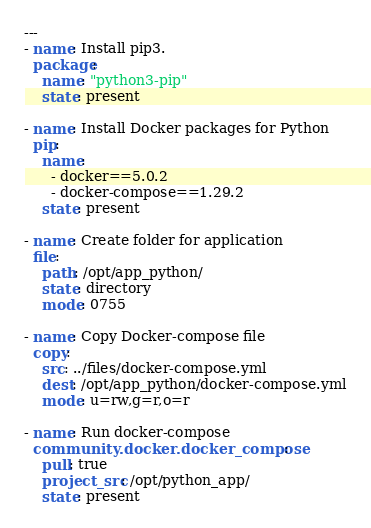Convert code to text. <code><loc_0><loc_0><loc_500><loc_500><_YAML_>---
- name: Install pip3.
  package:
    name: "python3-pip"
    state: present

- name: Install Docker packages for Python
  pip:
    name:
      - docker==5.0.2
      - docker-compose==1.29.2
    state: present

- name: Create folder for application
  file:
    path: /opt/app_python/
    state: directory
    mode: 0755

- name: Copy Docker-compose file
  copy:
    src: ../files/docker-compose.yml
    dest: /opt/app_python/docker-compose.yml
    mode: u=rw,g=r,o=r

- name: Run docker-compose
  community.docker.docker_compose:
    pull: true
    project_src: /opt/python_app/
    state: present
</code> 